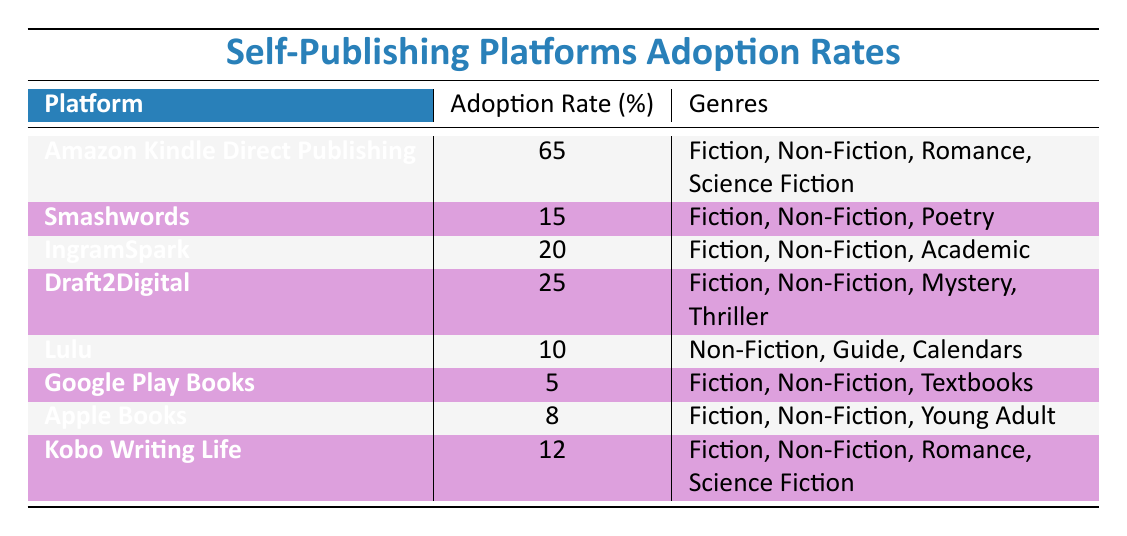What is the adoption rate of Amazon Kindle Direct Publishing? The table lists the adoption rate for Amazon Kindle Direct Publishing clearly as 65%.
Answer: 65% Which self-publishing platform has the lowest adoption rate? By comparing the adoption rates listed, Google Play Books has the lowest rate at 5%, which is lower than all other platforms listed.
Answer: Google Play Books How many genres does Draft2Digital support? Draft2Digital supports four genres: Fiction, Non-Fiction, Mystery, and Thriller, as listed in the genres column.
Answer: 4 What is the total adoption rate of platforms that support Romance as a genre? The platforms that support Romance are Amazon Kindle Direct Publishing (65%) and Kobo Writing Life (12%). Adding these gives 65 + 12 = 77.
Answer: 77 Is the adoption rate of Smashwords greater than that of Lulu? The adoption rate of Smashwords is 15% while Lulu's is 10%, so it is true that Smashwords has a greater adoption rate than Lulu.
Answer: Yes Which platform has an adoption rate between 10% and 20%, and what genre does it support? IngramSpark has an adoption rate of 20%, which is not between 10% and 20%, while Draft2Digital (25%) is too high. Lulu (10%) fits as well but does not exceed it, thus no platform fits strictly within these limits.
Answer: None If you sum the adoption rates of all platforms, what is the total? The adoption rates are summed as follows: 65 + 15 + 20 + 25 + 10 + 5 + 8 + 12 = 190.
Answer: 190 Which self-publishing platform supports both Fiction and Non-Fiction yet has a lower adoption rate than 15%? The platforms supporting both Fiction and Non-Fiction with a lower adoption rate than 15% have been examined: only Google Play Books can be considered, but its rate of 5% does not reflect this overlap adequately since its rate is the lowest amongst comparative Literature.
Answer: None 